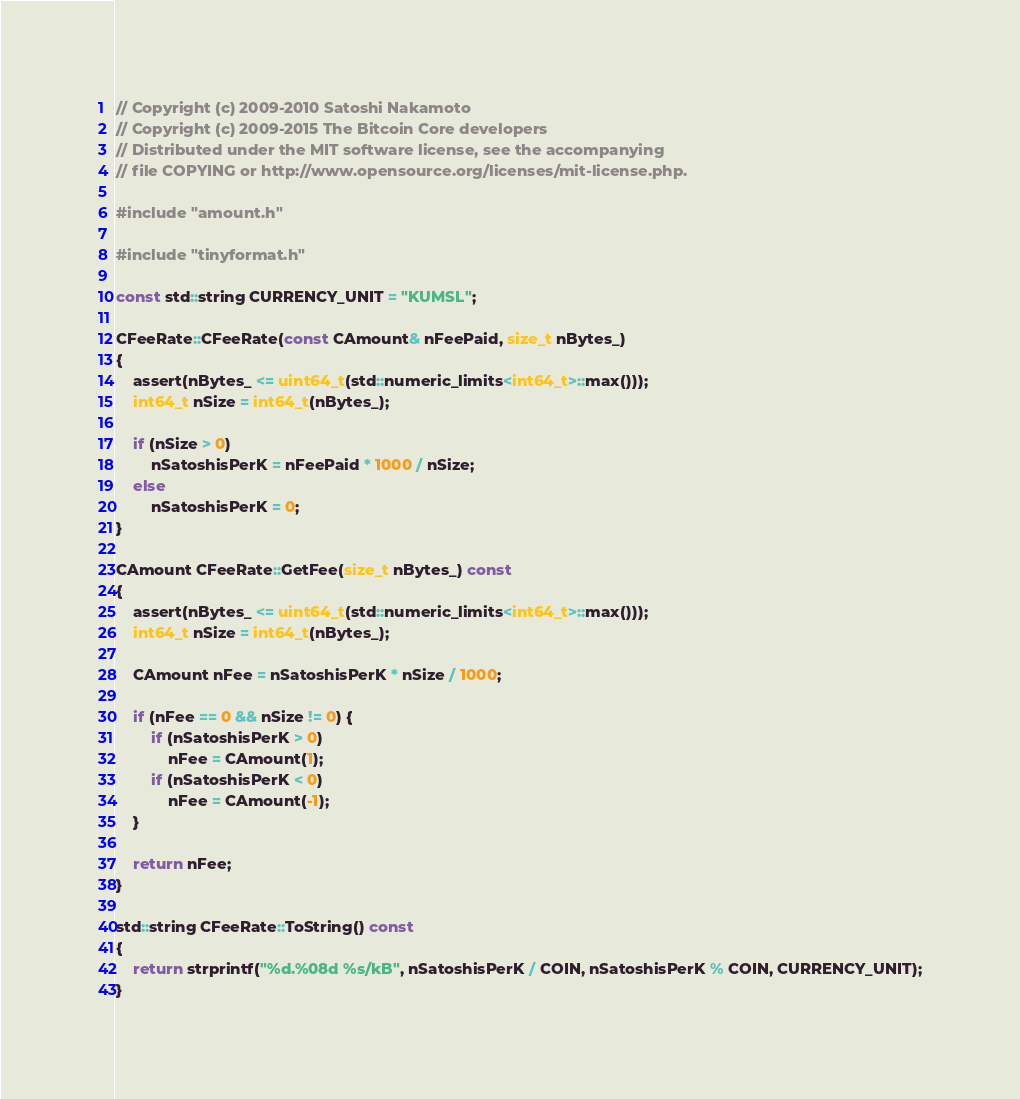Convert code to text. <code><loc_0><loc_0><loc_500><loc_500><_C++_>// Copyright (c) 2009-2010 Satoshi Nakamoto
// Copyright (c) 2009-2015 The Bitcoin Core developers
// Distributed under the MIT software license, see the accompanying
// file COPYING or http://www.opensource.org/licenses/mit-license.php.

#include "amount.h"

#include "tinyformat.h"

const std::string CURRENCY_UNIT = "KUMSL";

CFeeRate::CFeeRate(const CAmount& nFeePaid, size_t nBytes_)
{
    assert(nBytes_ <= uint64_t(std::numeric_limits<int64_t>::max()));
    int64_t nSize = int64_t(nBytes_);

    if (nSize > 0)
        nSatoshisPerK = nFeePaid * 1000 / nSize;
    else
        nSatoshisPerK = 0;
}

CAmount CFeeRate::GetFee(size_t nBytes_) const
{
    assert(nBytes_ <= uint64_t(std::numeric_limits<int64_t>::max()));
    int64_t nSize = int64_t(nBytes_);

    CAmount nFee = nSatoshisPerK * nSize / 1000;

    if (nFee == 0 && nSize != 0) {
        if (nSatoshisPerK > 0)
            nFee = CAmount(1);
        if (nSatoshisPerK < 0)
            nFee = CAmount(-1);
    }

    return nFee;
}

std::string CFeeRate::ToString() const
{
    return strprintf("%d.%08d %s/kB", nSatoshisPerK / COIN, nSatoshisPerK % COIN, CURRENCY_UNIT);
}
</code> 